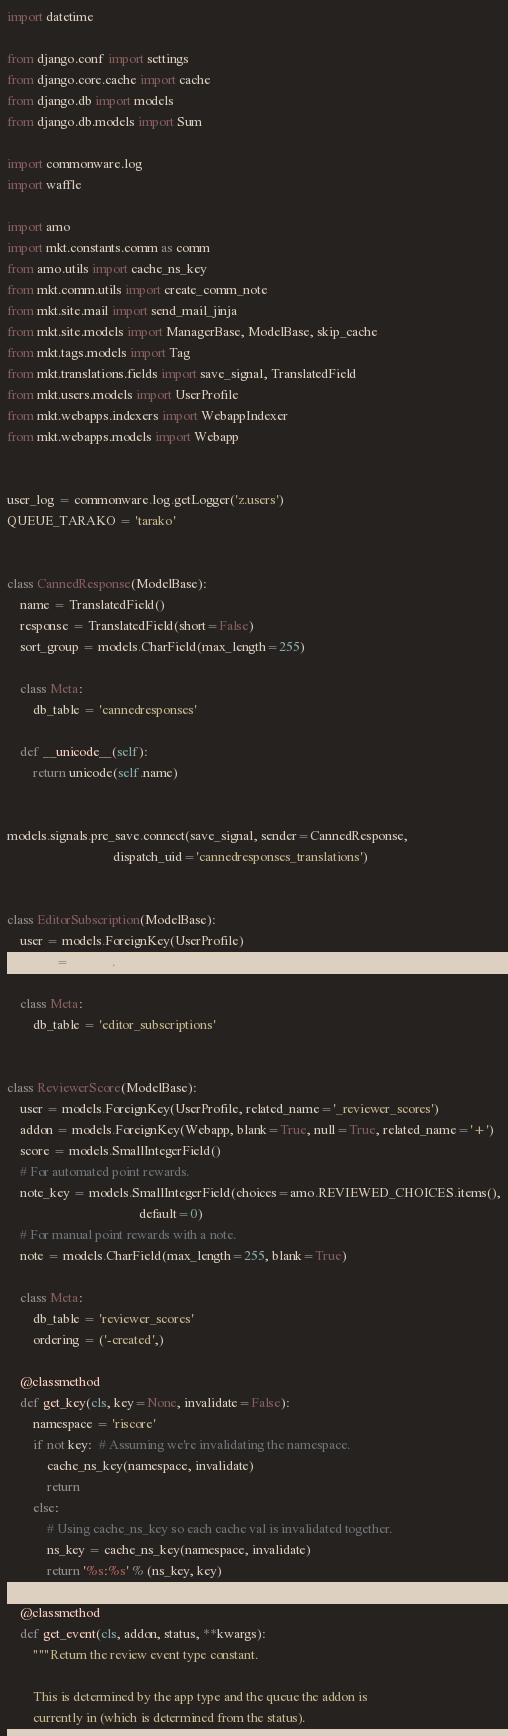Convert code to text. <code><loc_0><loc_0><loc_500><loc_500><_Python_>import datetime

from django.conf import settings
from django.core.cache import cache
from django.db import models
from django.db.models import Sum

import commonware.log
import waffle

import amo
import mkt.constants.comm as comm
from amo.utils import cache_ns_key
from mkt.comm.utils import create_comm_note
from mkt.site.mail import send_mail_jinja
from mkt.site.models import ManagerBase, ModelBase, skip_cache
from mkt.tags.models import Tag
from mkt.translations.fields import save_signal, TranslatedField
from mkt.users.models import UserProfile
from mkt.webapps.indexers import WebappIndexer
from mkt.webapps.models import Webapp


user_log = commonware.log.getLogger('z.users')
QUEUE_TARAKO = 'tarako'


class CannedResponse(ModelBase):
    name = TranslatedField()
    response = TranslatedField(short=False)
    sort_group = models.CharField(max_length=255)

    class Meta:
        db_table = 'cannedresponses'

    def __unicode__(self):
        return unicode(self.name)


models.signals.pre_save.connect(save_signal, sender=CannedResponse,
                                dispatch_uid='cannedresponses_translations')


class EditorSubscription(ModelBase):
    user = models.ForeignKey(UserProfile)
    addon = models.ForeignKey(Webapp)

    class Meta:
        db_table = 'editor_subscriptions'


class ReviewerScore(ModelBase):
    user = models.ForeignKey(UserProfile, related_name='_reviewer_scores')
    addon = models.ForeignKey(Webapp, blank=True, null=True, related_name='+')
    score = models.SmallIntegerField()
    # For automated point rewards.
    note_key = models.SmallIntegerField(choices=amo.REVIEWED_CHOICES.items(),
                                        default=0)
    # For manual point rewards with a note.
    note = models.CharField(max_length=255, blank=True)

    class Meta:
        db_table = 'reviewer_scores'
        ordering = ('-created',)

    @classmethod
    def get_key(cls, key=None, invalidate=False):
        namespace = 'riscore'
        if not key:  # Assuming we're invalidating the namespace.
            cache_ns_key(namespace, invalidate)
            return
        else:
            # Using cache_ns_key so each cache val is invalidated together.
            ns_key = cache_ns_key(namespace, invalidate)
            return '%s:%s' % (ns_key, key)

    @classmethod
    def get_event(cls, addon, status, **kwargs):
        """Return the review event type constant.

        This is determined by the app type and the queue the addon is
        currently in (which is determined from the status).
</code> 